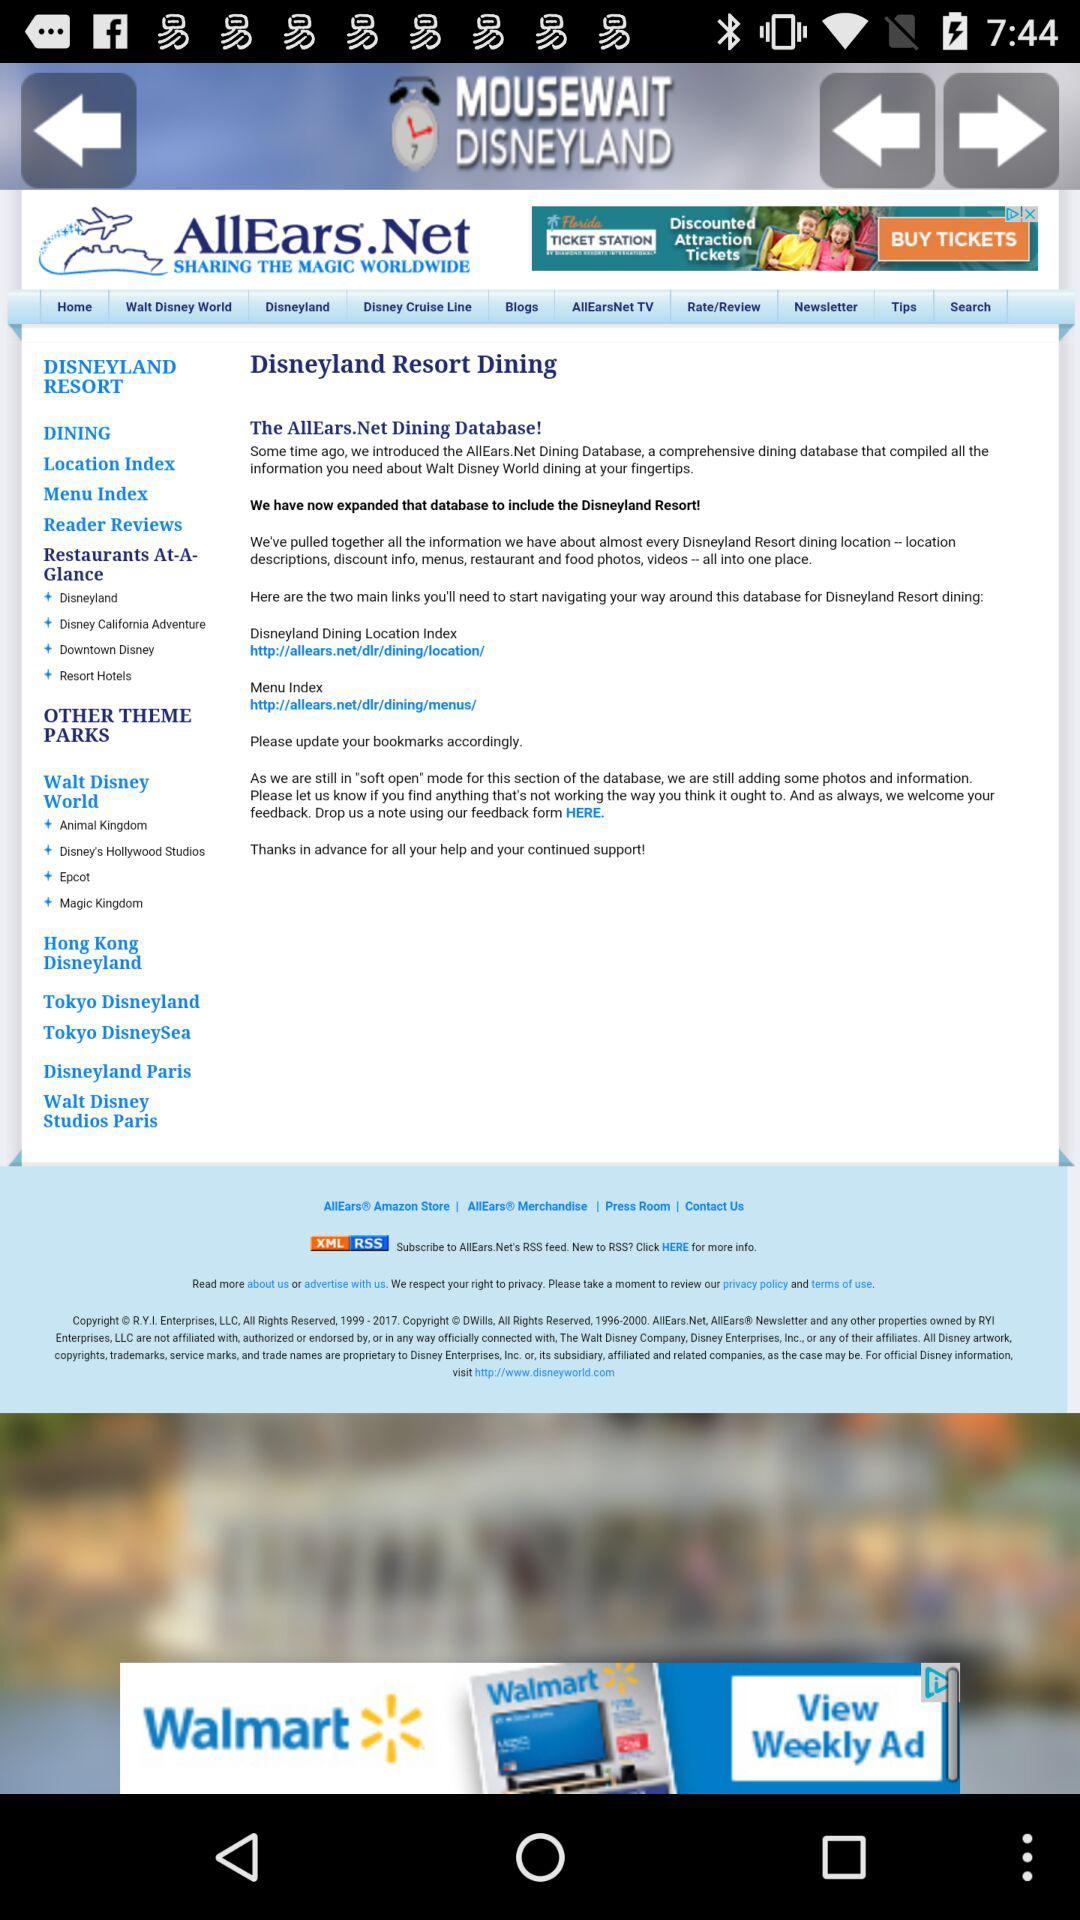What is the application name? The application name is "MOUSEWAIT DISNEYLAND". 